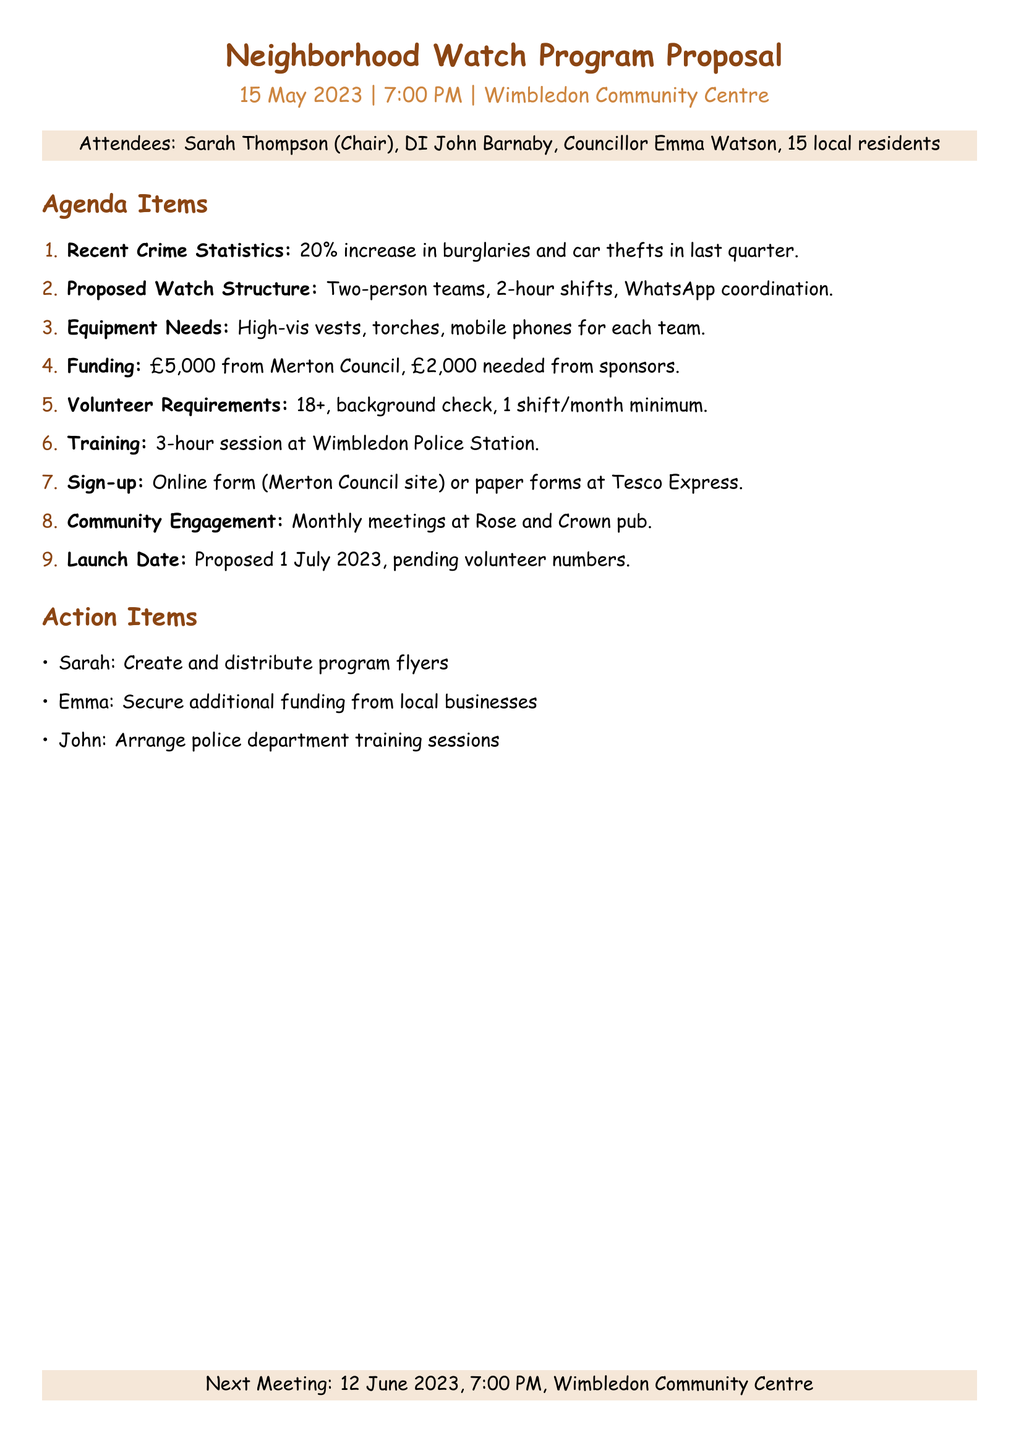What is the date of the meeting? The date of the meeting is explicitly stated in the document.
Answer: 15 May 2023 Who reported the recent crime statistics? The document mentions that Detective Inspector John Barnaby presented the crime statistics.
Answer: DI John Barnaby What percentage increase in burglaries was reported? The document specifies a 20% increase in burglaries and car thefts.
Answer: 20% What is the proposed start date of the neighborhood watch program? The document clearly states the proposed launch date of the program.
Answer: 1 July 2023 What is the minimum age requirement for volunteers? The document outlines the age requirement for volunteers in the volunteer requirements section.
Answer: 18+ How long will the training session last? The training program duration is mentioned in the agenda items.
Answer: 3-hour What equipment is needed for the watch teams? The document lists the equipment needs specifically for the teams.
Answer: High-visibility vests, torches, and mobile phones Where can volunteers sign up? The sign-up process is specified, listing the locations for signing up.
Answer: Merton Council website or Tesco Express 